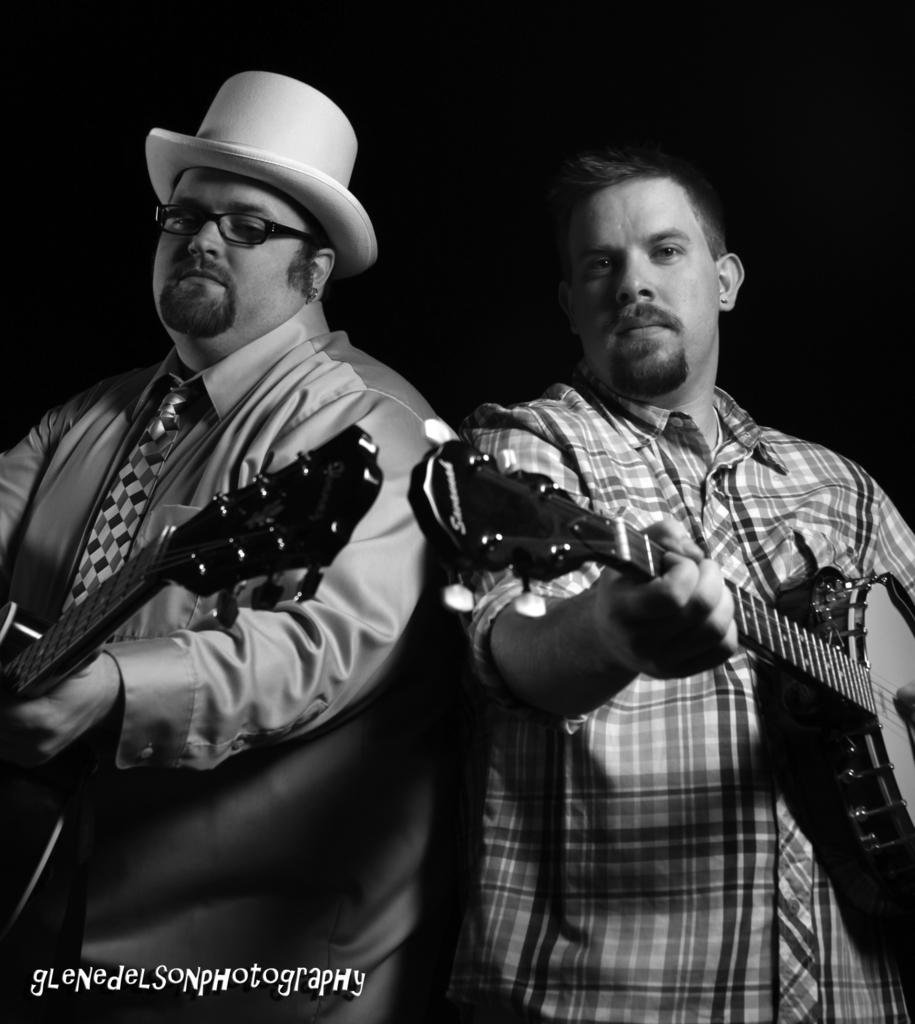What is the color scheme of the image? The image is black and white. How many people are in the image? There are two persons in the image. What are the two persons holding? The two persons are holding guitars. Where are the guitar-holding persons located in the image? The guitar-holding persons are in the center of the image. What can be found at the bottom of the image? There is text at the bottom of the image. Are there any bears playing the guitar in the image? No, there are no bears present in the image. What type of utensil is being used to play the guitar in the image? There are no utensils involved in playing the guitar in the image; the persons are using their hands. 